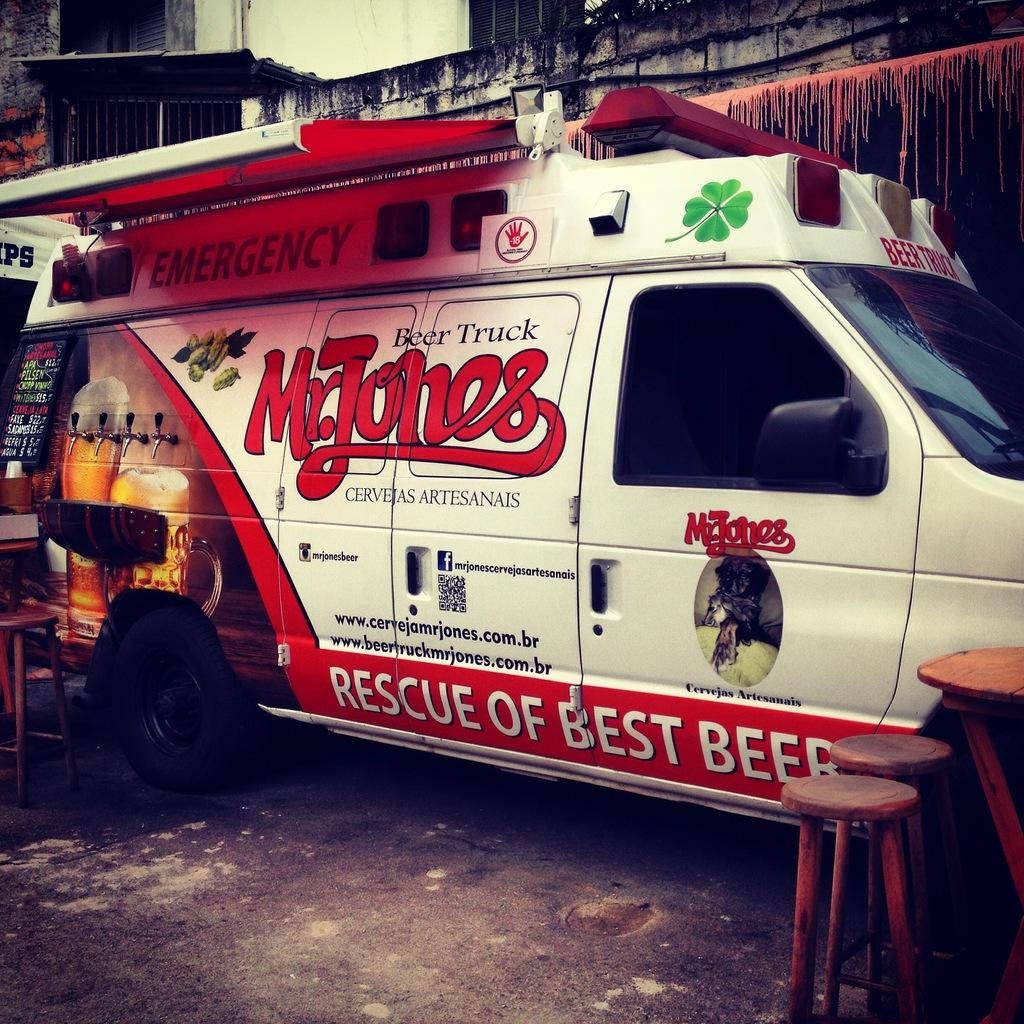What type of vehicle is in the image? There is a white color ambulance van in the image. Where is the ambulance van located? The ambulance van is parked on the roadside. What other object can be seen in the image? There is a wooden table in the image. What type of structure is visible in the background? There is an old wall visible in the image. What is the position of the nose on the ambulance van? The ambulance van does not have a nose, as it is a vehicle and not a living being. 